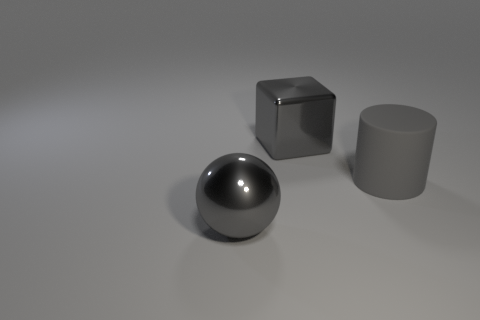Add 2 large gray metallic blocks. How many large gray metallic blocks are left? 3 Add 2 big red cylinders. How many big red cylinders exist? 2 Add 2 big gray balls. How many objects exist? 5 Subtract 0 purple spheres. How many objects are left? 3 Subtract 1 balls. How many balls are left? 0 Subtract all yellow cubes. Subtract all purple balls. How many cubes are left? 1 Subtract all big balls. Subtract all blocks. How many objects are left? 1 